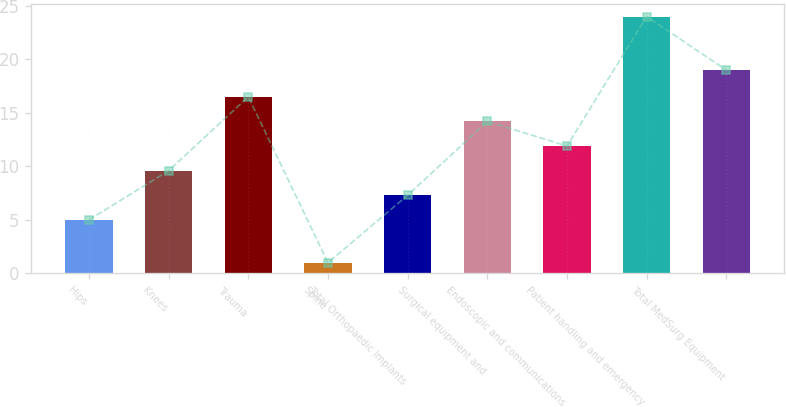Convert chart. <chart><loc_0><loc_0><loc_500><loc_500><bar_chart><fcel>Hips<fcel>Knees<fcel>Trauma<fcel>Spine<fcel>Total Orthopaedic Implants<fcel>Surgical equipment and<fcel>Endoscopic and communications<fcel>Patient handling and emergency<fcel>Total MedSurg Equipment<nl><fcel>5<fcel>9.6<fcel>16.5<fcel>1<fcel>7.3<fcel>14.2<fcel>11.9<fcel>24<fcel>19<nl></chart> 